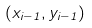<formula> <loc_0><loc_0><loc_500><loc_500>( x _ { i - 1 } , y _ { i - 1 } )</formula> 